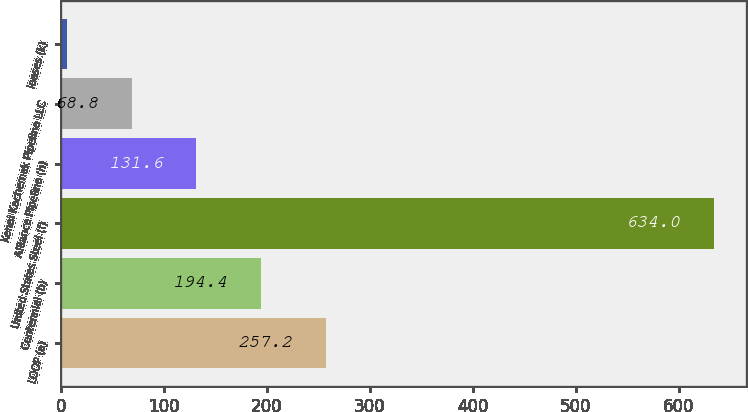Convert chart to OTSL. <chart><loc_0><loc_0><loc_500><loc_500><bar_chart><fcel>LOOP (a)<fcel>Centennial (b)<fcel>United States Steel (f)<fcel>Alliance Pipeline (h)<fcel>Kenai Kachemak Pipeline LLC<fcel>leases (k)<nl><fcel>257.2<fcel>194.4<fcel>634<fcel>131.6<fcel>68.8<fcel>6<nl></chart> 